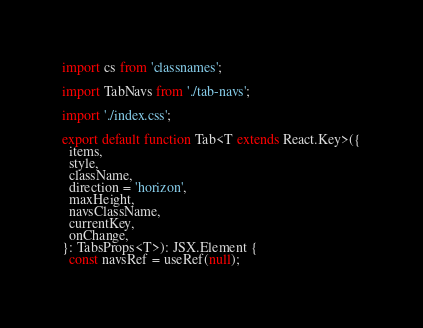<code> <loc_0><loc_0><loc_500><loc_500><_TypeScript_>import cs from 'classnames';

import TabNavs from './tab-navs';

import './index.css';

export default function Tab<T extends React.Key>({
  items,
  style,
  className,
  direction = 'horizon',
  maxHeight,
  navsClassName,
  currentKey,
  onChange,
}: TabsProps<T>): JSX.Element {
  const navsRef = useRef(null);</code> 